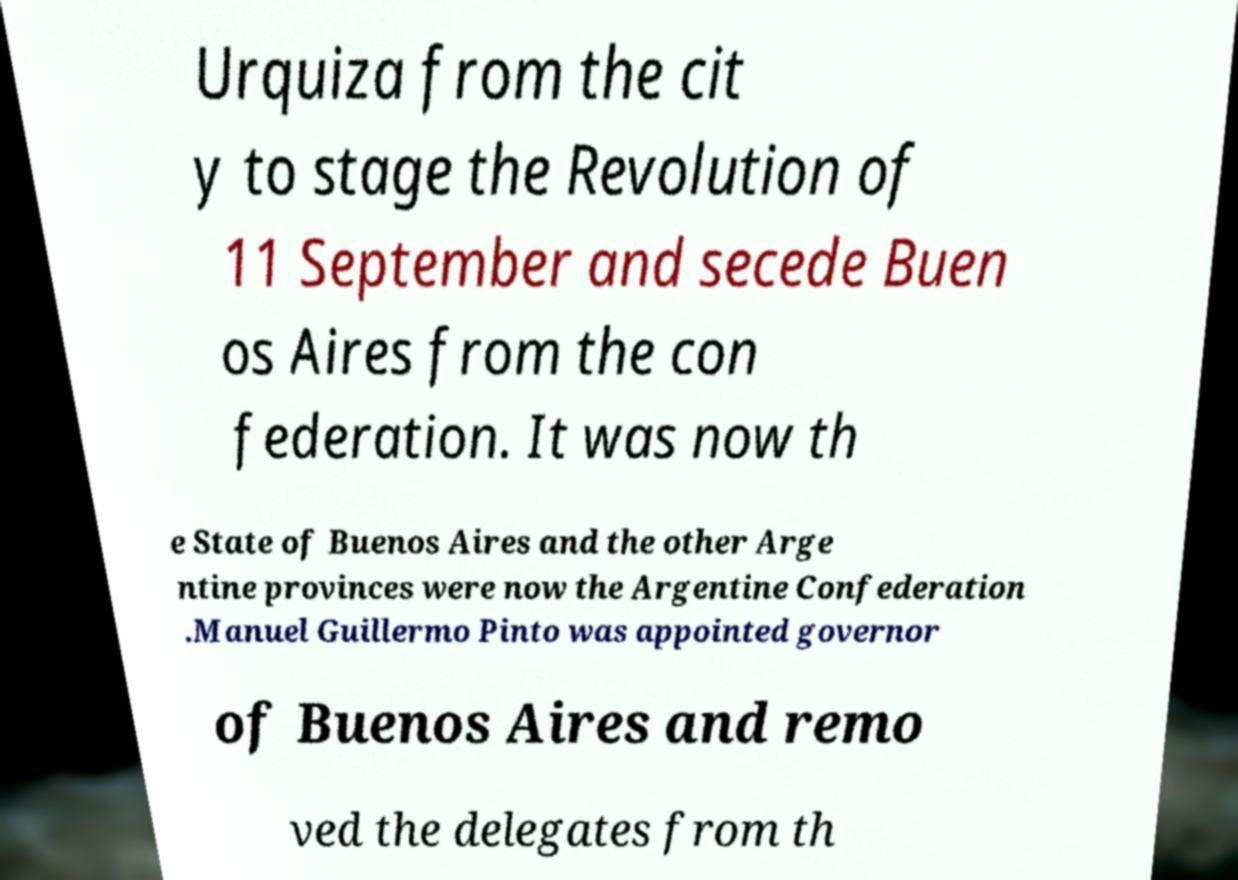What messages or text are displayed in this image? I need them in a readable, typed format. Urquiza from the cit y to stage the Revolution of 11 September and secede Buen os Aires from the con federation. It was now th e State of Buenos Aires and the other Arge ntine provinces were now the Argentine Confederation .Manuel Guillermo Pinto was appointed governor of Buenos Aires and remo ved the delegates from th 